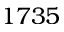<formula> <loc_0><loc_0><loc_500><loc_500>1 7 3 5</formula> 